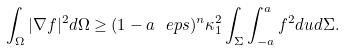Convert formula to latex. <formula><loc_0><loc_0><loc_500><loc_500>\int _ { \Omega } | \nabla f | ^ { 2 } d \Omega \geq ( 1 - a \ e p s ) ^ { n } \kappa _ { 1 } ^ { 2 } \int _ { \Sigma } \int ^ { a } _ { - a } f ^ { 2 } d u d \Sigma .</formula> 